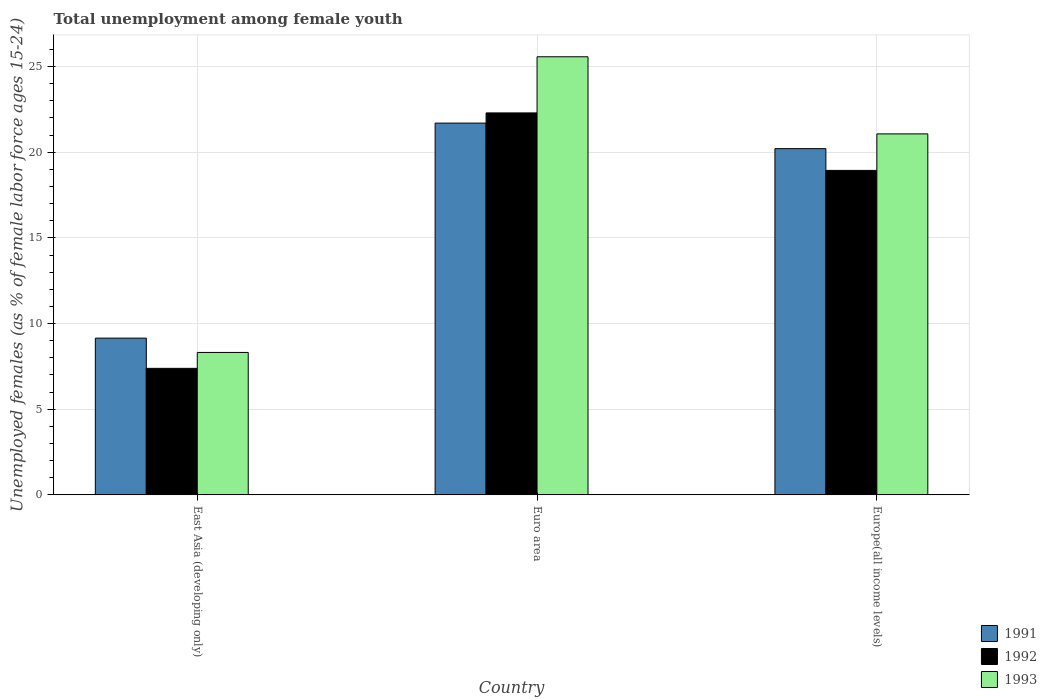How many groups of bars are there?
Offer a very short reply. 3. Are the number of bars per tick equal to the number of legend labels?
Offer a very short reply. Yes. Are the number of bars on each tick of the X-axis equal?
Offer a very short reply. Yes. How many bars are there on the 2nd tick from the left?
Your response must be concise. 3. What is the label of the 3rd group of bars from the left?
Provide a succinct answer. Europe(all income levels). What is the percentage of unemployed females in in 1991 in East Asia (developing only)?
Your response must be concise. 9.15. Across all countries, what is the maximum percentage of unemployed females in in 1991?
Ensure brevity in your answer.  21.7. Across all countries, what is the minimum percentage of unemployed females in in 1991?
Ensure brevity in your answer.  9.15. In which country was the percentage of unemployed females in in 1992 minimum?
Provide a succinct answer. East Asia (developing only). What is the total percentage of unemployed females in in 1992 in the graph?
Give a very brief answer. 48.62. What is the difference between the percentage of unemployed females in in 1992 in East Asia (developing only) and that in Europe(all income levels)?
Your answer should be very brief. -11.56. What is the difference between the percentage of unemployed females in in 1992 in East Asia (developing only) and the percentage of unemployed females in in 1993 in Euro area?
Offer a very short reply. -18.19. What is the average percentage of unemployed females in in 1992 per country?
Offer a terse response. 16.21. What is the difference between the percentage of unemployed females in of/in 1992 and percentage of unemployed females in of/in 1991 in Europe(all income levels)?
Provide a succinct answer. -1.27. What is the ratio of the percentage of unemployed females in in 1991 in East Asia (developing only) to that in Euro area?
Provide a succinct answer. 0.42. Is the percentage of unemployed females in in 1992 in East Asia (developing only) less than that in Euro area?
Your response must be concise. Yes. What is the difference between the highest and the second highest percentage of unemployed females in in 1991?
Give a very brief answer. -11.06. What is the difference between the highest and the lowest percentage of unemployed females in in 1993?
Offer a terse response. 17.26. In how many countries, is the percentage of unemployed females in in 1993 greater than the average percentage of unemployed females in in 1993 taken over all countries?
Your answer should be compact. 2. What does the 2nd bar from the left in East Asia (developing only) represents?
Offer a terse response. 1992. What does the 2nd bar from the right in Euro area represents?
Your answer should be very brief. 1992. Is it the case that in every country, the sum of the percentage of unemployed females in in 1992 and percentage of unemployed females in in 1993 is greater than the percentage of unemployed females in in 1991?
Offer a terse response. Yes. Are all the bars in the graph horizontal?
Ensure brevity in your answer.  No. How many countries are there in the graph?
Provide a short and direct response. 3. What is the difference between two consecutive major ticks on the Y-axis?
Your answer should be very brief. 5. Does the graph contain any zero values?
Keep it short and to the point. No. Does the graph contain grids?
Provide a short and direct response. Yes. Where does the legend appear in the graph?
Offer a terse response. Bottom right. How many legend labels are there?
Your answer should be very brief. 3. What is the title of the graph?
Ensure brevity in your answer.  Total unemployment among female youth. What is the label or title of the Y-axis?
Your response must be concise. Unemployed females (as % of female labor force ages 15-24). What is the Unemployed females (as % of female labor force ages 15-24) in 1991 in East Asia (developing only)?
Your answer should be very brief. 9.15. What is the Unemployed females (as % of female labor force ages 15-24) of 1992 in East Asia (developing only)?
Your answer should be very brief. 7.38. What is the Unemployed females (as % of female labor force ages 15-24) of 1993 in East Asia (developing only)?
Make the answer very short. 8.31. What is the Unemployed females (as % of female labor force ages 15-24) of 1991 in Euro area?
Give a very brief answer. 21.7. What is the Unemployed females (as % of female labor force ages 15-24) of 1992 in Euro area?
Keep it short and to the point. 22.3. What is the Unemployed females (as % of female labor force ages 15-24) in 1993 in Euro area?
Offer a terse response. 25.57. What is the Unemployed females (as % of female labor force ages 15-24) of 1991 in Europe(all income levels)?
Offer a very short reply. 20.21. What is the Unemployed females (as % of female labor force ages 15-24) of 1992 in Europe(all income levels)?
Provide a succinct answer. 18.94. What is the Unemployed females (as % of female labor force ages 15-24) in 1993 in Europe(all income levels)?
Your response must be concise. 21.07. Across all countries, what is the maximum Unemployed females (as % of female labor force ages 15-24) of 1991?
Provide a succinct answer. 21.7. Across all countries, what is the maximum Unemployed females (as % of female labor force ages 15-24) of 1992?
Your answer should be very brief. 22.3. Across all countries, what is the maximum Unemployed females (as % of female labor force ages 15-24) of 1993?
Your answer should be compact. 25.57. Across all countries, what is the minimum Unemployed females (as % of female labor force ages 15-24) of 1991?
Your answer should be compact. 9.15. Across all countries, what is the minimum Unemployed females (as % of female labor force ages 15-24) of 1992?
Give a very brief answer. 7.38. Across all countries, what is the minimum Unemployed females (as % of female labor force ages 15-24) of 1993?
Provide a short and direct response. 8.31. What is the total Unemployed females (as % of female labor force ages 15-24) of 1991 in the graph?
Provide a succinct answer. 51.06. What is the total Unemployed females (as % of female labor force ages 15-24) in 1992 in the graph?
Keep it short and to the point. 48.62. What is the total Unemployed females (as % of female labor force ages 15-24) in 1993 in the graph?
Give a very brief answer. 54.96. What is the difference between the Unemployed females (as % of female labor force ages 15-24) of 1991 in East Asia (developing only) and that in Euro area?
Offer a very short reply. -12.56. What is the difference between the Unemployed females (as % of female labor force ages 15-24) in 1992 in East Asia (developing only) and that in Euro area?
Offer a terse response. -14.91. What is the difference between the Unemployed females (as % of female labor force ages 15-24) of 1993 in East Asia (developing only) and that in Euro area?
Ensure brevity in your answer.  -17.26. What is the difference between the Unemployed females (as % of female labor force ages 15-24) in 1991 in East Asia (developing only) and that in Europe(all income levels)?
Provide a succinct answer. -11.06. What is the difference between the Unemployed females (as % of female labor force ages 15-24) in 1992 in East Asia (developing only) and that in Europe(all income levels)?
Your answer should be compact. -11.56. What is the difference between the Unemployed females (as % of female labor force ages 15-24) of 1993 in East Asia (developing only) and that in Europe(all income levels)?
Make the answer very short. -12.76. What is the difference between the Unemployed females (as % of female labor force ages 15-24) in 1991 in Euro area and that in Europe(all income levels)?
Offer a very short reply. 1.49. What is the difference between the Unemployed females (as % of female labor force ages 15-24) of 1992 in Euro area and that in Europe(all income levels)?
Offer a very short reply. 3.36. What is the difference between the Unemployed females (as % of female labor force ages 15-24) in 1993 in Euro area and that in Europe(all income levels)?
Make the answer very short. 4.5. What is the difference between the Unemployed females (as % of female labor force ages 15-24) of 1991 in East Asia (developing only) and the Unemployed females (as % of female labor force ages 15-24) of 1992 in Euro area?
Give a very brief answer. -13.15. What is the difference between the Unemployed females (as % of female labor force ages 15-24) of 1991 in East Asia (developing only) and the Unemployed females (as % of female labor force ages 15-24) of 1993 in Euro area?
Make the answer very short. -16.43. What is the difference between the Unemployed females (as % of female labor force ages 15-24) of 1992 in East Asia (developing only) and the Unemployed females (as % of female labor force ages 15-24) of 1993 in Euro area?
Give a very brief answer. -18.19. What is the difference between the Unemployed females (as % of female labor force ages 15-24) in 1991 in East Asia (developing only) and the Unemployed females (as % of female labor force ages 15-24) in 1992 in Europe(all income levels)?
Keep it short and to the point. -9.79. What is the difference between the Unemployed females (as % of female labor force ages 15-24) of 1991 in East Asia (developing only) and the Unemployed females (as % of female labor force ages 15-24) of 1993 in Europe(all income levels)?
Give a very brief answer. -11.93. What is the difference between the Unemployed females (as % of female labor force ages 15-24) of 1992 in East Asia (developing only) and the Unemployed females (as % of female labor force ages 15-24) of 1993 in Europe(all income levels)?
Ensure brevity in your answer.  -13.69. What is the difference between the Unemployed females (as % of female labor force ages 15-24) in 1991 in Euro area and the Unemployed females (as % of female labor force ages 15-24) in 1992 in Europe(all income levels)?
Your response must be concise. 2.76. What is the difference between the Unemployed females (as % of female labor force ages 15-24) in 1991 in Euro area and the Unemployed females (as % of female labor force ages 15-24) in 1993 in Europe(all income levels)?
Ensure brevity in your answer.  0.63. What is the difference between the Unemployed females (as % of female labor force ages 15-24) in 1992 in Euro area and the Unemployed females (as % of female labor force ages 15-24) in 1993 in Europe(all income levels)?
Offer a terse response. 1.22. What is the average Unemployed females (as % of female labor force ages 15-24) of 1991 per country?
Offer a very short reply. 17.02. What is the average Unemployed females (as % of female labor force ages 15-24) of 1992 per country?
Make the answer very short. 16.21. What is the average Unemployed females (as % of female labor force ages 15-24) of 1993 per country?
Your answer should be very brief. 18.32. What is the difference between the Unemployed females (as % of female labor force ages 15-24) in 1991 and Unemployed females (as % of female labor force ages 15-24) in 1992 in East Asia (developing only)?
Your answer should be compact. 1.76. What is the difference between the Unemployed females (as % of female labor force ages 15-24) in 1991 and Unemployed females (as % of female labor force ages 15-24) in 1993 in East Asia (developing only)?
Ensure brevity in your answer.  0.84. What is the difference between the Unemployed females (as % of female labor force ages 15-24) in 1992 and Unemployed females (as % of female labor force ages 15-24) in 1993 in East Asia (developing only)?
Your answer should be compact. -0.93. What is the difference between the Unemployed females (as % of female labor force ages 15-24) in 1991 and Unemployed females (as % of female labor force ages 15-24) in 1992 in Euro area?
Offer a terse response. -0.59. What is the difference between the Unemployed females (as % of female labor force ages 15-24) in 1991 and Unemployed females (as % of female labor force ages 15-24) in 1993 in Euro area?
Provide a short and direct response. -3.87. What is the difference between the Unemployed females (as % of female labor force ages 15-24) of 1992 and Unemployed females (as % of female labor force ages 15-24) of 1993 in Euro area?
Offer a terse response. -3.28. What is the difference between the Unemployed females (as % of female labor force ages 15-24) of 1991 and Unemployed females (as % of female labor force ages 15-24) of 1992 in Europe(all income levels)?
Offer a very short reply. 1.27. What is the difference between the Unemployed females (as % of female labor force ages 15-24) of 1991 and Unemployed females (as % of female labor force ages 15-24) of 1993 in Europe(all income levels)?
Ensure brevity in your answer.  -0.86. What is the difference between the Unemployed females (as % of female labor force ages 15-24) of 1992 and Unemployed females (as % of female labor force ages 15-24) of 1993 in Europe(all income levels)?
Ensure brevity in your answer.  -2.13. What is the ratio of the Unemployed females (as % of female labor force ages 15-24) of 1991 in East Asia (developing only) to that in Euro area?
Offer a terse response. 0.42. What is the ratio of the Unemployed females (as % of female labor force ages 15-24) in 1992 in East Asia (developing only) to that in Euro area?
Offer a terse response. 0.33. What is the ratio of the Unemployed females (as % of female labor force ages 15-24) of 1993 in East Asia (developing only) to that in Euro area?
Make the answer very short. 0.33. What is the ratio of the Unemployed females (as % of female labor force ages 15-24) in 1991 in East Asia (developing only) to that in Europe(all income levels)?
Ensure brevity in your answer.  0.45. What is the ratio of the Unemployed females (as % of female labor force ages 15-24) of 1992 in East Asia (developing only) to that in Europe(all income levels)?
Your answer should be compact. 0.39. What is the ratio of the Unemployed females (as % of female labor force ages 15-24) of 1993 in East Asia (developing only) to that in Europe(all income levels)?
Your answer should be compact. 0.39. What is the ratio of the Unemployed females (as % of female labor force ages 15-24) of 1991 in Euro area to that in Europe(all income levels)?
Provide a short and direct response. 1.07. What is the ratio of the Unemployed females (as % of female labor force ages 15-24) in 1992 in Euro area to that in Europe(all income levels)?
Ensure brevity in your answer.  1.18. What is the ratio of the Unemployed females (as % of female labor force ages 15-24) in 1993 in Euro area to that in Europe(all income levels)?
Offer a terse response. 1.21. What is the difference between the highest and the second highest Unemployed females (as % of female labor force ages 15-24) in 1991?
Offer a terse response. 1.49. What is the difference between the highest and the second highest Unemployed females (as % of female labor force ages 15-24) in 1992?
Your response must be concise. 3.36. What is the difference between the highest and the second highest Unemployed females (as % of female labor force ages 15-24) in 1993?
Your answer should be very brief. 4.5. What is the difference between the highest and the lowest Unemployed females (as % of female labor force ages 15-24) in 1991?
Ensure brevity in your answer.  12.56. What is the difference between the highest and the lowest Unemployed females (as % of female labor force ages 15-24) in 1992?
Your response must be concise. 14.91. What is the difference between the highest and the lowest Unemployed females (as % of female labor force ages 15-24) in 1993?
Ensure brevity in your answer.  17.26. 